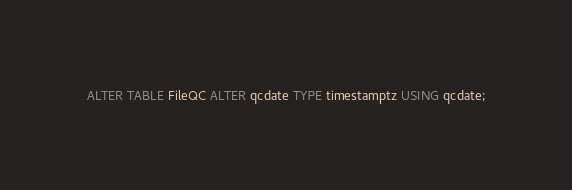Convert code to text. <code><loc_0><loc_0><loc_500><loc_500><_SQL_>ALTER TABLE FileQC ALTER qcdate TYPE timestamptz USING qcdate;</code> 